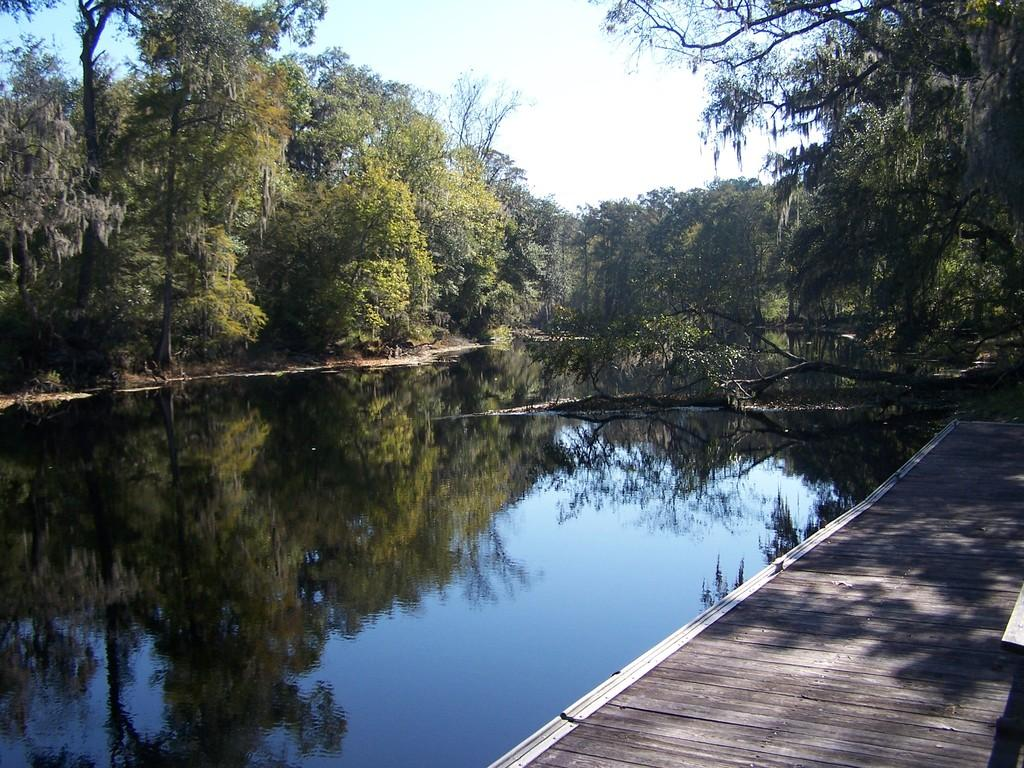What type of vegetation is present in the image? There are trees with branches and leaves in the image. What natural feature can be seen in the image? There is a lake with water in the image. Is there any man-made structure visible in the image? Yes, there appears to be a wooden pathway in the image. What is visible above the trees and lake in the image? The sky is visible in the image. What type of meal is being prepared on the wooden pathway in the image? There is no meal being prepared or present in the image; the wooden pathway is simply a feature of the landscape. 